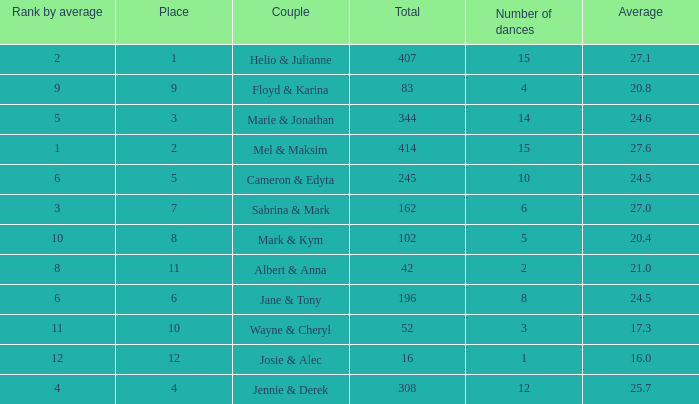What is the average place for a couple with the rank by average of 9 and total smaller than 83? None. 